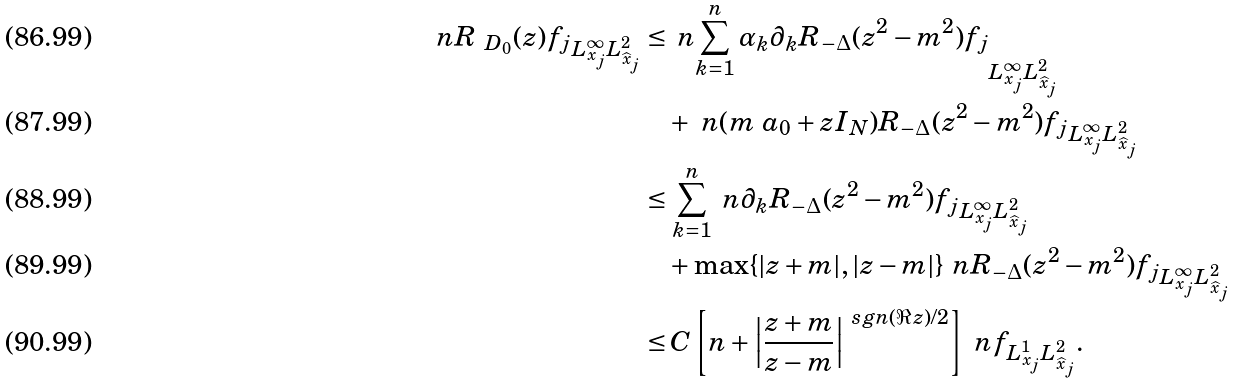<formula> <loc_0><loc_0><loc_500><loc_500>\ n { R _ { \ D _ { 0 } } ( z ) f _ { j } } _ { L ^ { \infty } _ { x _ { j } } L ^ { 2 } _ { \widehat { x } _ { j } } } \leq & \, \ n { \sum _ { k = 1 } ^ { n } \alpha _ { k } \partial _ { k } R _ { - \Delta } ( z ^ { 2 } - m ^ { 2 } ) f _ { j } } _ { L ^ { \infty } _ { x _ { j } } L ^ { 2 } _ { \widehat { x } _ { j } } } \\ & + \ n { ( m \ a _ { 0 } + z I _ { N } ) R _ { - \Delta } ( z ^ { 2 } - m ^ { 2 } ) f _ { j } } _ { L ^ { \infty } _ { x _ { j } } L ^ { 2 } _ { \widehat { x } _ { j } } } \\ \leq & \, \sum _ { k = 1 } ^ { n } \ n { \partial _ { k } R _ { - \Delta } ( z ^ { 2 } - m ^ { 2 } ) f _ { j } } _ { L ^ { \infty } _ { x _ { j } } L ^ { 2 } _ { \widehat { x } _ { j } } } \\ & + \max \{ | z + m | , | z - m | \} \ n { R _ { - \Delta } ( z ^ { 2 } - m ^ { 2 } ) f _ { j } } _ { L ^ { \infty } _ { x _ { j } } L ^ { 2 } _ { \widehat { x } _ { j } } } \\ \leq & \, C \left [ n + \left | \frac { z + m } { z - m } \right | ^ { \ s g n ( \Re z ) / 2 } \right ] \ n { f } _ { L ^ { 1 } _ { x _ { j } } L ^ { 2 } _ { \widehat { x } _ { j } } } .</formula> 